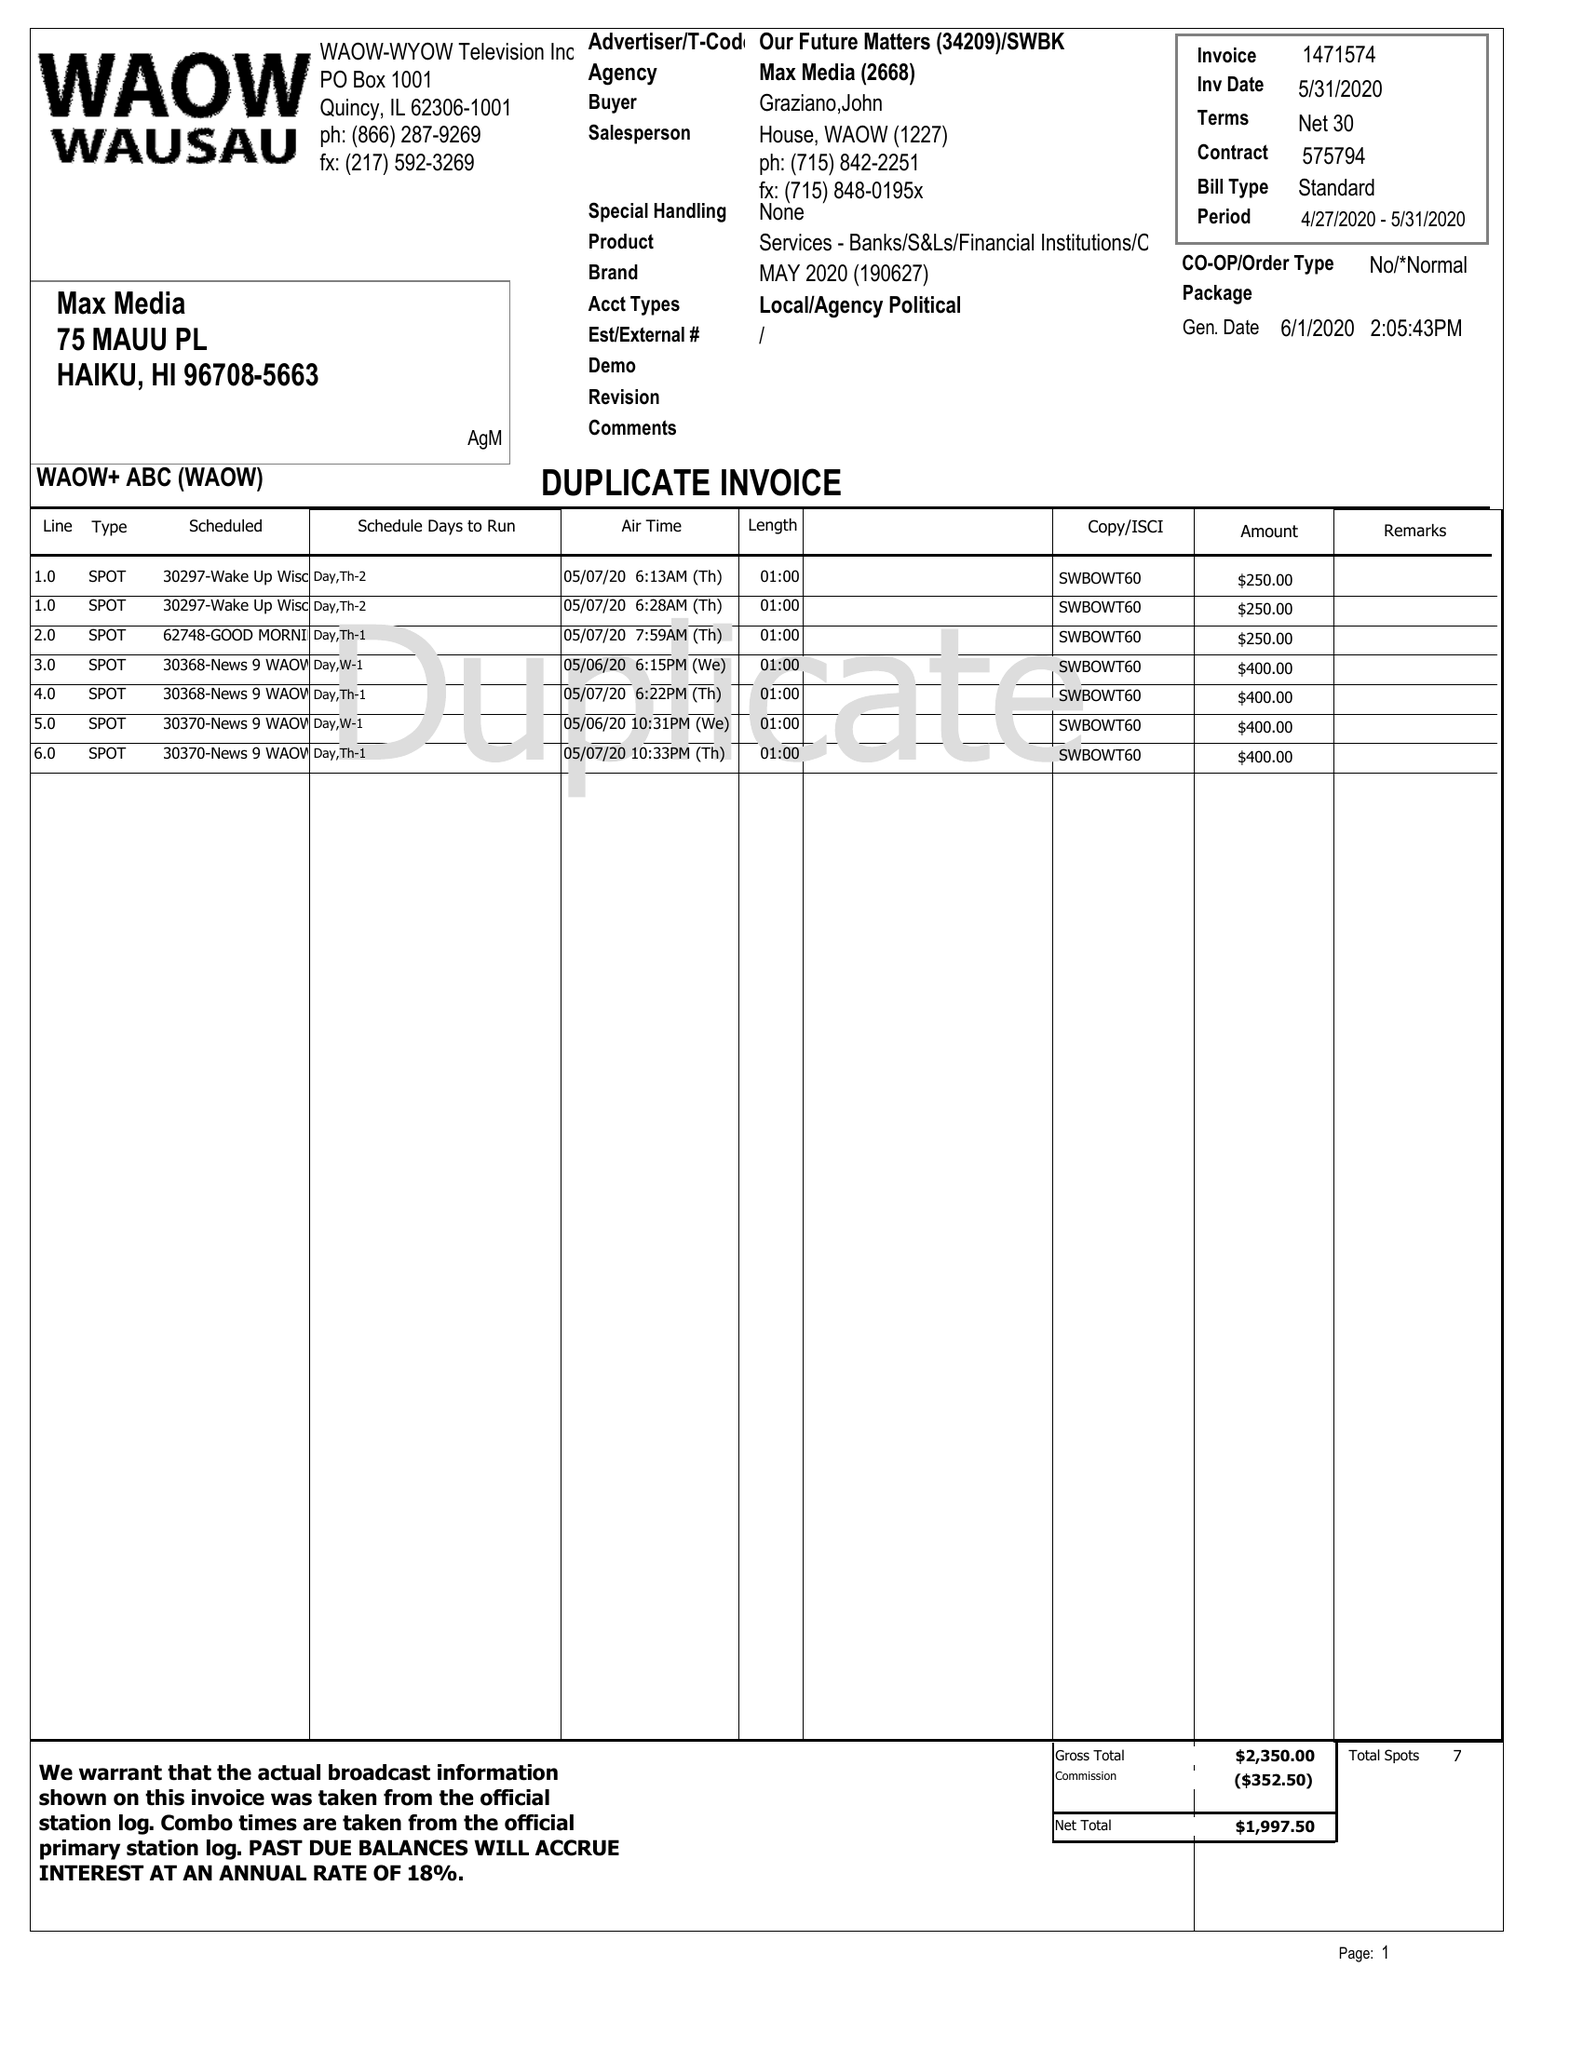What is the value for the advertiser?
Answer the question using a single word or phrase. OUR FUTURE MATTERS 